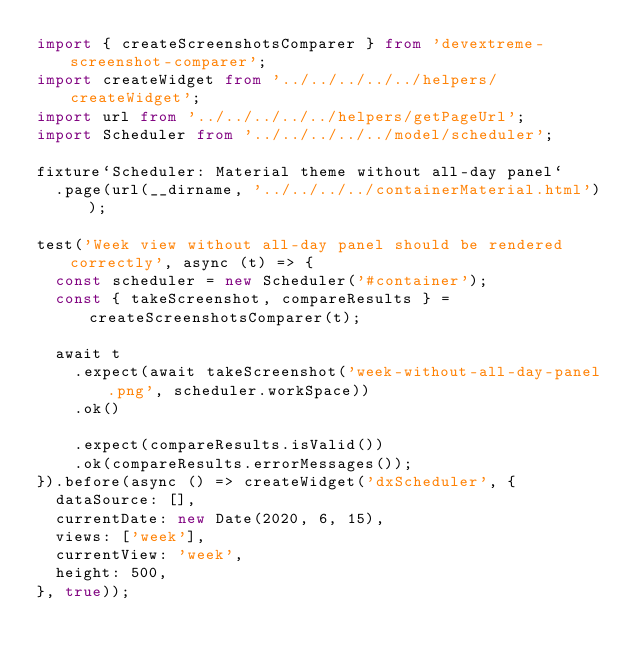Convert code to text. <code><loc_0><loc_0><loc_500><loc_500><_TypeScript_>import { createScreenshotsComparer } from 'devextreme-screenshot-comparer';
import createWidget from '../../../../../helpers/createWidget';
import url from '../../../../../helpers/getPageUrl';
import Scheduler from '../../../../../model/scheduler';

fixture`Scheduler: Material theme without all-day panel`
  .page(url(__dirname, '../../../../containerMaterial.html'));

test('Week view without all-day panel should be rendered correctly', async (t) => {
  const scheduler = new Scheduler('#container');
  const { takeScreenshot, compareResults } = createScreenshotsComparer(t);

  await t
    .expect(await takeScreenshot('week-without-all-day-panel.png', scheduler.workSpace))
    .ok()

    .expect(compareResults.isValid())
    .ok(compareResults.errorMessages());
}).before(async () => createWidget('dxScheduler', {
  dataSource: [],
  currentDate: new Date(2020, 6, 15),
  views: ['week'],
  currentView: 'week',
  height: 500,
}, true));
</code> 